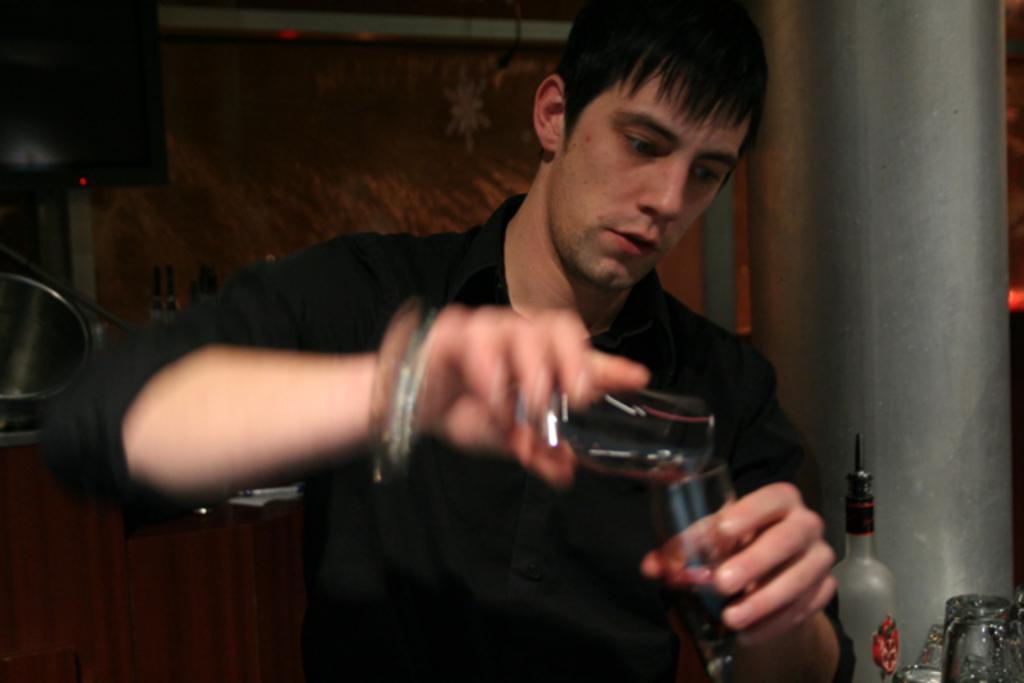How would you summarize this image in a sentence or two? A man is standing and mixing the wine with his hands, he wore a black color shirt. 